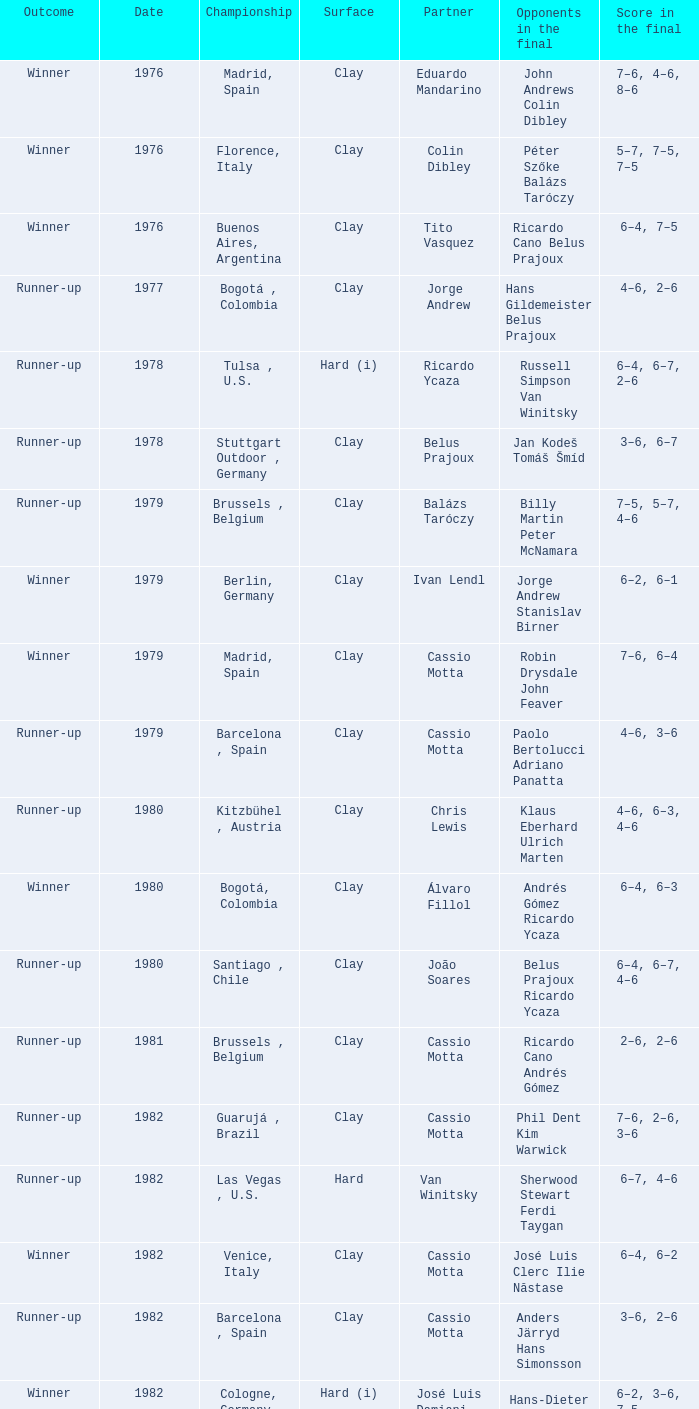Give me the full table as a dictionary. {'header': ['Outcome', 'Date', 'Championship', 'Surface', 'Partner', 'Opponents in the final', 'Score in the final'], 'rows': [['Winner', '1976', 'Madrid, Spain', 'Clay', 'Eduardo Mandarino', 'John Andrews Colin Dibley', '7–6, 4–6, 8–6'], ['Winner', '1976', 'Florence, Italy', 'Clay', 'Colin Dibley', 'Péter Szőke Balázs Taróczy', '5–7, 7–5, 7–5'], ['Winner', '1976', 'Buenos Aires, Argentina', 'Clay', 'Tito Vasquez', 'Ricardo Cano Belus Prajoux', '6–4, 7–5'], ['Runner-up', '1977', 'Bogotá , Colombia', 'Clay', 'Jorge Andrew', 'Hans Gildemeister Belus Prajoux', '4–6, 2–6'], ['Runner-up', '1978', 'Tulsa , U.S.', 'Hard (i)', 'Ricardo Ycaza', 'Russell Simpson Van Winitsky', '6–4, 6–7, 2–6'], ['Runner-up', '1978', 'Stuttgart Outdoor , Germany', 'Clay', 'Belus Prajoux', 'Jan Kodeš Tomáš Šmíd', '3–6, 6–7'], ['Runner-up', '1979', 'Brussels , Belgium', 'Clay', 'Balázs Taróczy', 'Billy Martin Peter McNamara', '7–5, 5–7, 4–6'], ['Winner', '1979', 'Berlin, Germany', 'Clay', 'Ivan Lendl', 'Jorge Andrew Stanislav Birner', '6–2, 6–1'], ['Winner', '1979', 'Madrid, Spain', 'Clay', 'Cassio Motta', 'Robin Drysdale John Feaver', '7–6, 6–4'], ['Runner-up', '1979', 'Barcelona , Spain', 'Clay', 'Cassio Motta', 'Paolo Bertolucci Adriano Panatta', '4–6, 3–6'], ['Runner-up', '1980', 'Kitzbühel , Austria', 'Clay', 'Chris Lewis', 'Klaus Eberhard Ulrich Marten', '4–6, 6–3, 4–6'], ['Winner', '1980', 'Bogotá, Colombia', 'Clay', 'Álvaro Fillol', 'Andrés Gómez Ricardo Ycaza', '6–4, 6–3'], ['Runner-up', '1980', 'Santiago , Chile', 'Clay', 'João Soares', 'Belus Prajoux Ricardo Ycaza', '6–4, 6–7, 4–6'], ['Runner-up', '1981', 'Brussels , Belgium', 'Clay', 'Cassio Motta', 'Ricardo Cano Andrés Gómez', '2–6, 2–6'], ['Runner-up', '1982', 'Guarujá , Brazil', 'Clay', 'Cassio Motta', 'Phil Dent Kim Warwick', '7–6, 2–6, 3–6'], ['Runner-up', '1982', 'Las Vegas , U.S.', 'Hard', 'Van Winitsky', 'Sherwood Stewart Ferdi Taygan', '6–7, 4–6'], ['Winner', '1982', 'Venice, Italy', 'Clay', 'Cassio Motta', 'José Luis Clerc Ilie Năstase', '6–4, 6–2'], ['Runner-up', '1982', 'Barcelona , Spain', 'Clay', 'Cassio Motta', 'Anders Järryd Hans Simonsson', '3–6, 2–6'], ['Winner', '1982', 'Cologne, Germany', 'Hard (i)', 'José Luis Damiani', 'Hans-Dieter Beutel Christoph Zipf', '6–2, 3–6, 7–5'], ['Winner', '1982', 'São Paulo, Brazil', 'Clay', 'Cassio Motta', 'Peter McNamara Ferdi Taygan', '6–3, 6–1'], ['Winner', '1983', 'Lisbon, Portugal', 'Clay', 'Cassio Motta', 'Pavel Složil Ferdi Taygan', '7–5, 6–4'], ['Runner-up', '1983', 'Indianapolis , U.S.', 'Clay', 'Cassio Motta', 'Mark Edmondson Sherwood Stewart', '3–6, 2–6'], ['Runner-up', '1983', 'Cincinnati , U.S.', 'Hard', 'Cassio Motta', 'Victor Amaya Tim Gullikson', '4–6, 3–6'], ['Runner-up', '1985', 'Geneva , Switzerland', 'Clay', 'Cassio Motta', 'Sergio Casal Emilio Sánchez', '4–6, 6–4, 5–7']]} What was the surface in 1981? Clay. 